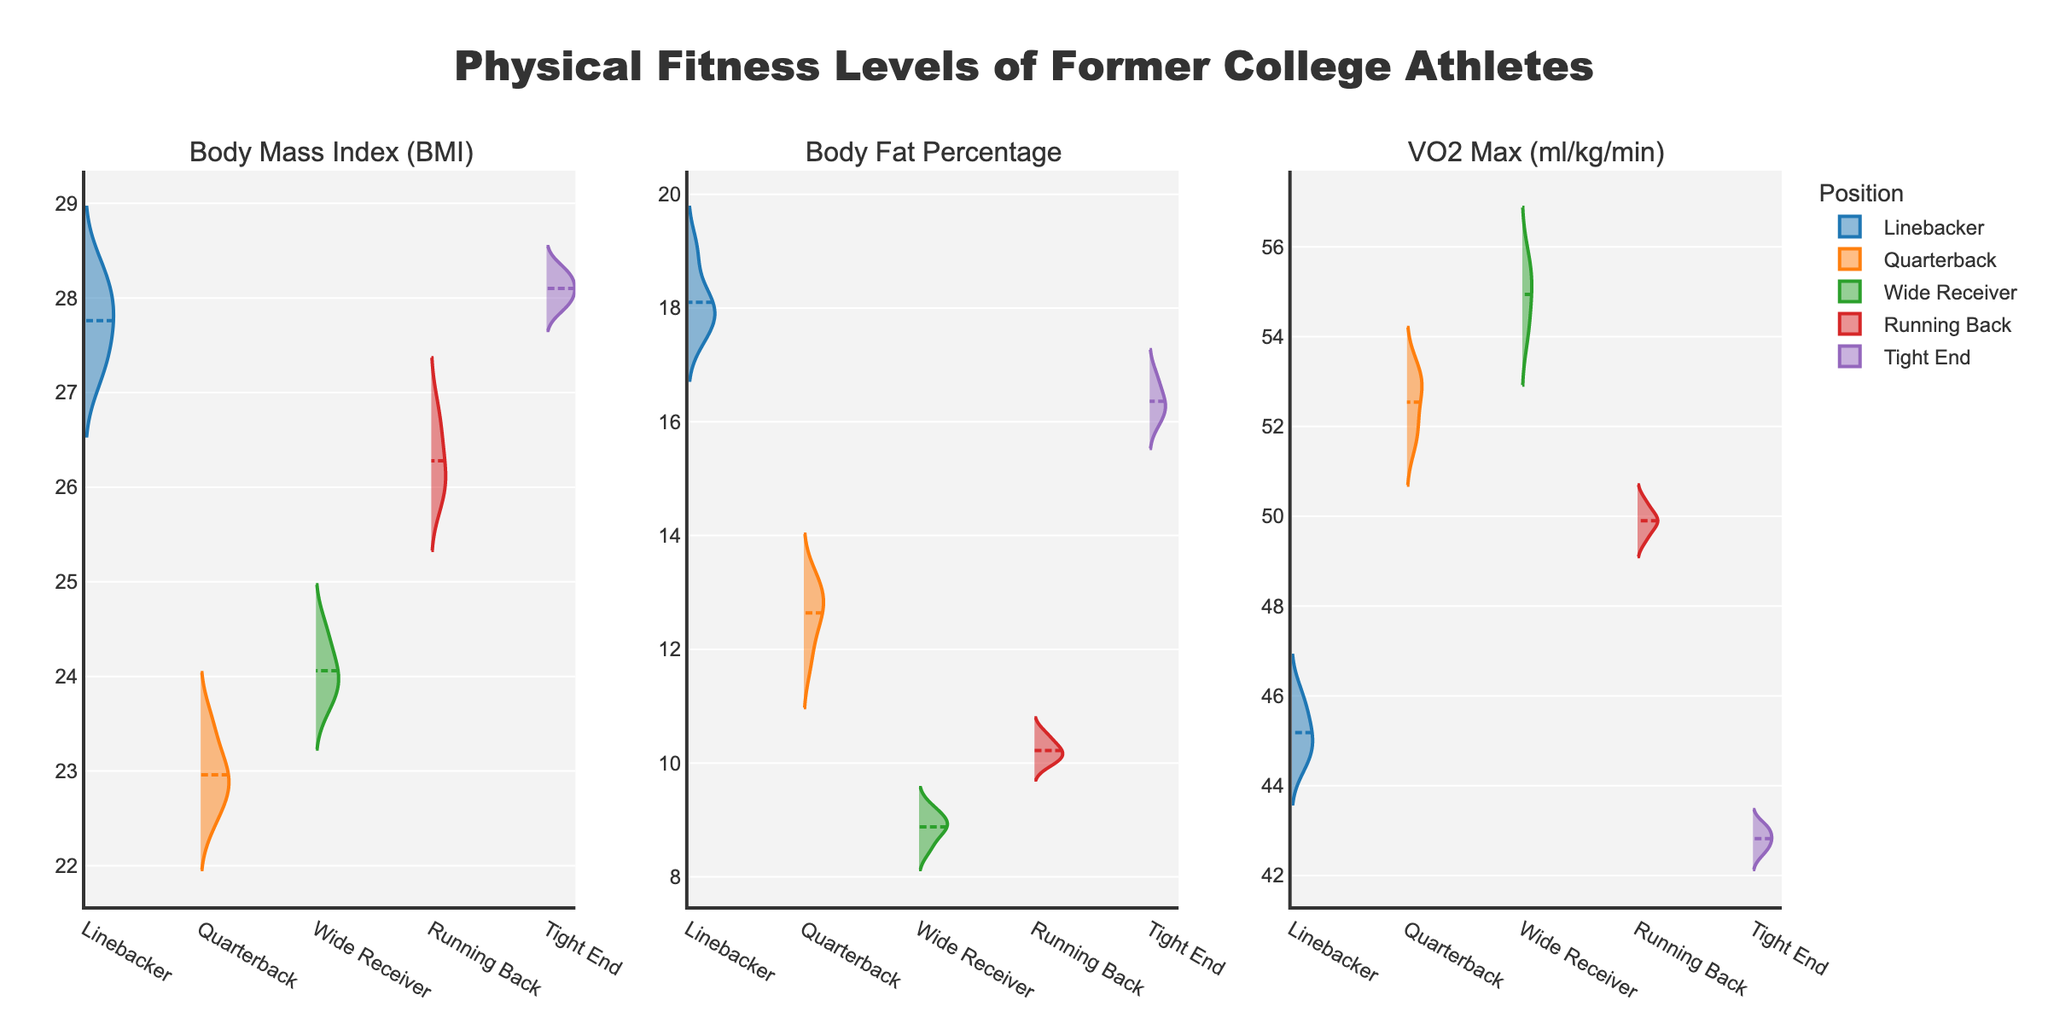What is the title of the figure? The title is usually at the top of the figure. In this case, it is mentioned in the code and would be at the top of the rendered plot.
Answer: Physical Fitness Levels of Former College Athletes How many different positions are represented in the subplots? By observing the different categories on the x-axis in any of the subplots, you can count the unique positions.
Answer: 5 Which position has the highest average VO2 Max? Look at the third subplot titled "VO2 Max (ml/kg/min)", then compare the mean lines for each position. The quarterback and wide receiver positions appear to have higher values. Based on the dashed mean lines, the wide receiver shows the highest.
Answer: Wide Receiver Which position has the widest range in Body Mass Index (BMI)? In the first subplot, titled "Body Mass Index (BMI)", look at the range (height) of the violin plots for each position. The linebacker and tight end positions have relatively wide ranges. The linebacker position has a noticeably wider range.
Answer: Linebacker What is the Body Fat Percentage for the player with the least and most body fat? In the second subplot titled "Body Fat Percentage", identify the lowest and highest points in the violin plots. The lowest body fat percentage is in Wide Receivers, and the highest is among the Linebackers.
Answer: 8.5% (lowest), 19.0% (highest) Which position has the least variability in VO2 Max? Focus on the width and spread of the violin plots in the third subplot titled "VO2 Max (ml/kg/min)". The running back and tight end positions appear narrower, indicating less variability. However, running back appears to be the narrowest.
Answer: Running Back Compare the average Body Fat Percentage between Linebackers and Quarterbacks. Which group has a higher average? In the second subplot titled "Body Fat Percentage", observe the mean lines for each position. The Linebackers' mean line is higher than the Quarterbacks' mean line.
Answer: Linebackers What's the median Body Mass Index (BMI) for the Tight Ends? The median is typically represented by the line in the center of the violin plot. For the Tight Ends in the first subplot, identify this line.
Answer: ~28 How do the VO2 Max values of the Linebackers compare to those of the Running Backs? In the third subplot titled "VO2 Max (ml/kg/min)", compare the Linebackers' and Running Backs' violin plots in terms of overall placement and distribution. Running Backs generally have higher values than Linebackers.
Answer: Running Backs have higher VO2 Max values Are there any overlaps in Body Mass Index (BMI) distribution among the positions? In the first subplot titled "Body Mass Index (BMI)", check if the violin plots for different positions overlap horizontally. There is some overlap among several positions, notably between Linebackers and Tight Ends.
Answer: Yes 